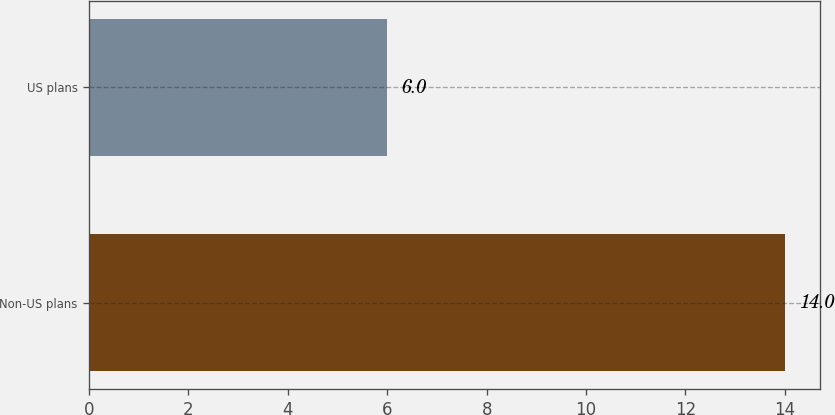<chart> <loc_0><loc_0><loc_500><loc_500><bar_chart><fcel>Non-US plans<fcel>US plans<nl><fcel>14<fcel>6<nl></chart> 